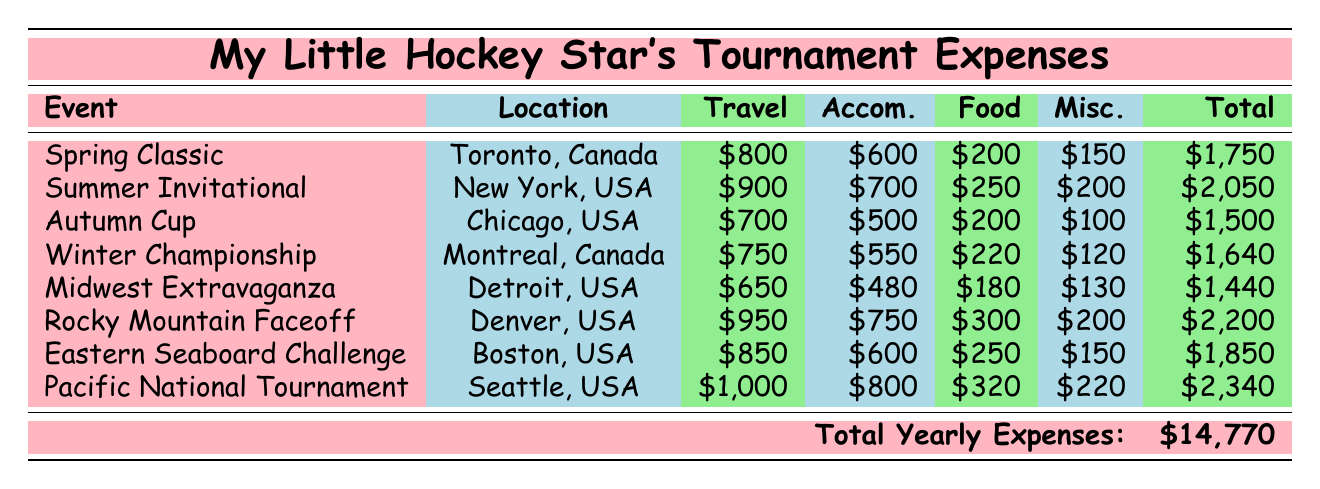What is the total cost for travel to the Summer Invitational? The travel cost for the Summer Invitational is listed in the table as $900.
Answer: 900 Which tournament has the highest total cost? The tournament with the highest total cost is the Pacific National Tournament, which is $2,340.
Answer: 2,340 How much does food cost for the Winter Championship? The food cost for the Winter Championship is specified as $220 in the table.
Answer: 220 What is the average accommodation cost across all tournaments? To find the average accommodation cost, add all accommodation costs: (600 + 700 + 500 + 550 + 480 + 750 + 600 + 800 = 4,480). There are 8 tournaments, so the average is 4,480 / 8 = 560.
Answer: 560 Is the total cost for the Autumn Cup less than $1,600? The total cost for the Autumn Cup is $1,500, which is indeed less than $1,600, making the statement true.
Answer: Yes What is the difference in total cost between the Rocky Mountain Faceoff and the Eastern Seaboard Challenge? The total cost for Rocky Mountain Faceoff is $2,200 and for Eastern Seaboard Challenge it is $1,850. The difference is $2,200 - $1,850 = $350.
Answer: 350 Which event costs less than $1,500 for travel and accommodation combined? To find this, add travel and accommodation costs for each event. Only Midwest Extravaganza (Travel: $650 + Accommodation: $480 = $1,130) and Autumn Cup (Travel: $700 + Accommodation: $500 = $1,200) meet this criterion as both are below $1,500.
Answer: Midwest Extravaganza, Autumn Cup Did the events in Canada generally have lower total costs than those in the USA? The total costs for the Canadian events (Spring Classic: $1,750 and Winter Championship: $1,640) are $3,390. The total costs for the events in the USA are $1,500 (Autumn Cup) + $2,050 (Summer Invitational) + $1,440 (Midwest Extravaganza) + $2,200 (Rocky Mountain Faceoff) + $1,850 (Eastern Seaboard Challenge) + $2,340 (Pacific National Tournament) = $11,380. $3,390 is less than $11,380, so the statement is true.
Answer: Yes What is the percentage of the total yearly expenses spent on food? The total yearly expenses are $14,770 and the total food costs are (200 + 250 + 200 + 220 + 180 + 300 + 250 + 320 = 1,920). To find the percentage, divide $1,920 by $14,770 and multiply by 100: (1,920 / 14,770) * 100 ≈ 12.99%.
Answer: Approximately 13% 